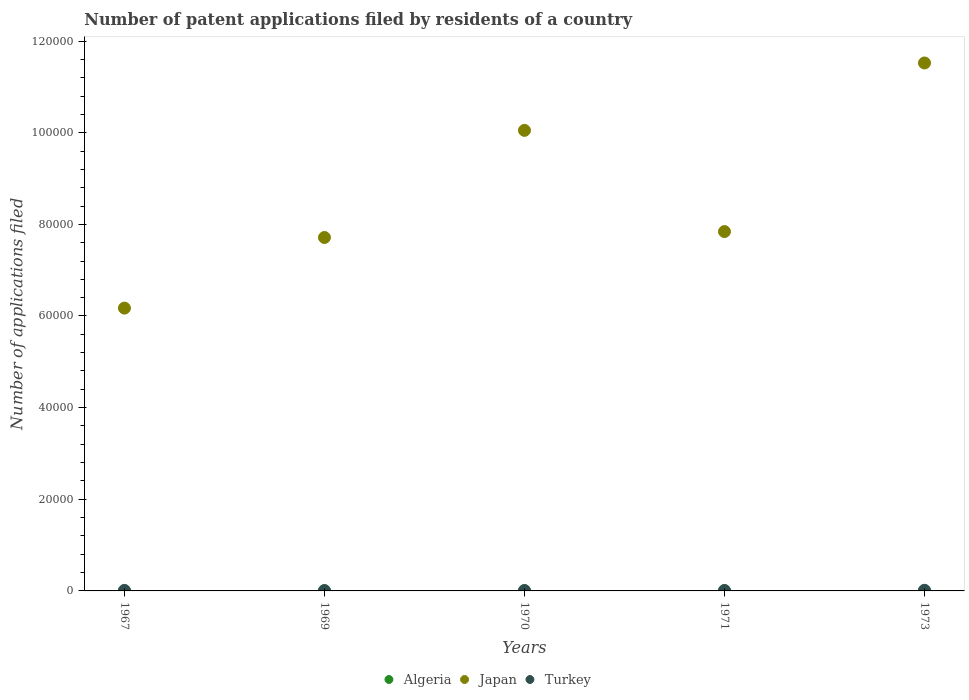Across all years, what is the maximum number of applications filed in Turkey?
Your response must be concise. 137. Across all years, what is the minimum number of applications filed in Japan?
Your answer should be very brief. 6.17e+04. In which year was the number of applications filed in Algeria minimum?
Keep it short and to the point. 1967. What is the total number of applications filed in Turkey in the graph?
Provide a short and direct response. 514. What is the difference between the number of applications filed in Algeria in 1967 and that in 1971?
Your response must be concise. -9. What is the difference between the number of applications filed in Algeria in 1969 and the number of applications filed in Japan in 1973?
Offer a very short reply. -1.15e+05. What is the average number of applications filed in Japan per year?
Offer a terse response. 8.66e+04. In the year 1971, what is the difference between the number of applications filed in Algeria and number of applications filed in Japan?
Provide a succinct answer. -7.84e+04. What is the ratio of the number of applications filed in Japan in 1967 to that in 1973?
Keep it short and to the point. 0.54. Is the number of applications filed in Algeria in 1970 less than that in 1973?
Ensure brevity in your answer.  No. Is the difference between the number of applications filed in Algeria in 1970 and 1971 greater than the difference between the number of applications filed in Japan in 1970 and 1971?
Give a very brief answer. No. What is the difference between the highest and the lowest number of applications filed in Turkey?
Keep it short and to the point. 52. In how many years, is the number of applications filed in Algeria greater than the average number of applications filed in Algeria taken over all years?
Ensure brevity in your answer.  2. Is the sum of the number of applications filed in Japan in 1967 and 1970 greater than the maximum number of applications filed in Turkey across all years?
Make the answer very short. Yes. Is it the case that in every year, the sum of the number of applications filed in Algeria and number of applications filed in Turkey  is greater than the number of applications filed in Japan?
Ensure brevity in your answer.  No. Does the number of applications filed in Japan monotonically increase over the years?
Offer a very short reply. No. Is the number of applications filed in Turkey strictly less than the number of applications filed in Algeria over the years?
Offer a very short reply. No. How many dotlines are there?
Offer a very short reply. 3. How many years are there in the graph?
Give a very brief answer. 5. What is the difference between two consecutive major ticks on the Y-axis?
Provide a succinct answer. 2.00e+04. Are the values on the major ticks of Y-axis written in scientific E-notation?
Make the answer very short. No. Does the graph contain any zero values?
Provide a short and direct response. No. Does the graph contain grids?
Make the answer very short. No. Where does the legend appear in the graph?
Offer a terse response. Bottom center. What is the title of the graph?
Offer a terse response. Number of patent applications filed by residents of a country. What is the label or title of the X-axis?
Keep it short and to the point. Years. What is the label or title of the Y-axis?
Offer a terse response. Number of applications filed. What is the Number of applications filed of Algeria in 1967?
Keep it short and to the point. 5. What is the Number of applications filed in Japan in 1967?
Provide a short and direct response. 6.17e+04. What is the Number of applications filed of Turkey in 1967?
Your answer should be very brief. 107. What is the Number of applications filed in Japan in 1969?
Offer a terse response. 7.71e+04. What is the Number of applications filed in Japan in 1970?
Keep it short and to the point. 1.01e+05. What is the Number of applications filed of Turkey in 1970?
Make the answer very short. 89. What is the Number of applications filed of Japan in 1971?
Provide a succinct answer. 7.84e+04. What is the Number of applications filed of Turkey in 1971?
Provide a succinct answer. 96. What is the Number of applications filed in Algeria in 1973?
Offer a very short reply. 7. What is the Number of applications filed in Japan in 1973?
Keep it short and to the point. 1.15e+05. What is the Number of applications filed in Turkey in 1973?
Your answer should be compact. 137. Across all years, what is the maximum Number of applications filed of Japan?
Offer a terse response. 1.15e+05. Across all years, what is the maximum Number of applications filed of Turkey?
Your response must be concise. 137. Across all years, what is the minimum Number of applications filed of Japan?
Keep it short and to the point. 6.17e+04. Across all years, what is the minimum Number of applications filed of Turkey?
Your response must be concise. 85. What is the total Number of applications filed of Algeria in the graph?
Provide a short and direct response. 51. What is the total Number of applications filed in Japan in the graph?
Give a very brief answer. 4.33e+05. What is the total Number of applications filed in Turkey in the graph?
Your answer should be very brief. 514. What is the difference between the Number of applications filed in Japan in 1967 and that in 1969?
Make the answer very short. -1.54e+04. What is the difference between the Number of applications filed in Turkey in 1967 and that in 1969?
Offer a very short reply. 22. What is the difference between the Number of applications filed of Japan in 1967 and that in 1970?
Ensure brevity in your answer.  -3.88e+04. What is the difference between the Number of applications filed in Turkey in 1967 and that in 1970?
Keep it short and to the point. 18. What is the difference between the Number of applications filed of Algeria in 1967 and that in 1971?
Offer a terse response. -9. What is the difference between the Number of applications filed of Japan in 1967 and that in 1971?
Ensure brevity in your answer.  -1.67e+04. What is the difference between the Number of applications filed of Turkey in 1967 and that in 1971?
Offer a terse response. 11. What is the difference between the Number of applications filed in Algeria in 1967 and that in 1973?
Provide a succinct answer. -2. What is the difference between the Number of applications filed of Japan in 1967 and that in 1973?
Provide a short and direct response. -5.35e+04. What is the difference between the Number of applications filed in Algeria in 1969 and that in 1970?
Offer a very short reply. -11. What is the difference between the Number of applications filed of Japan in 1969 and that in 1970?
Offer a terse response. -2.34e+04. What is the difference between the Number of applications filed in Algeria in 1969 and that in 1971?
Provide a succinct answer. -7. What is the difference between the Number of applications filed in Japan in 1969 and that in 1971?
Provide a short and direct response. -1293. What is the difference between the Number of applications filed in Algeria in 1969 and that in 1973?
Keep it short and to the point. 0. What is the difference between the Number of applications filed in Japan in 1969 and that in 1973?
Ensure brevity in your answer.  -3.81e+04. What is the difference between the Number of applications filed in Turkey in 1969 and that in 1973?
Give a very brief answer. -52. What is the difference between the Number of applications filed of Japan in 1970 and that in 1971?
Your response must be concise. 2.21e+04. What is the difference between the Number of applications filed of Algeria in 1970 and that in 1973?
Provide a succinct answer. 11. What is the difference between the Number of applications filed of Japan in 1970 and that in 1973?
Your response must be concise. -1.47e+04. What is the difference between the Number of applications filed of Turkey in 1970 and that in 1973?
Keep it short and to the point. -48. What is the difference between the Number of applications filed in Algeria in 1971 and that in 1973?
Provide a succinct answer. 7. What is the difference between the Number of applications filed in Japan in 1971 and that in 1973?
Give a very brief answer. -3.68e+04. What is the difference between the Number of applications filed of Turkey in 1971 and that in 1973?
Provide a short and direct response. -41. What is the difference between the Number of applications filed in Algeria in 1967 and the Number of applications filed in Japan in 1969?
Your answer should be compact. -7.71e+04. What is the difference between the Number of applications filed of Algeria in 1967 and the Number of applications filed of Turkey in 1969?
Provide a short and direct response. -80. What is the difference between the Number of applications filed of Japan in 1967 and the Number of applications filed of Turkey in 1969?
Your answer should be very brief. 6.16e+04. What is the difference between the Number of applications filed of Algeria in 1967 and the Number of applications filed of Japan in 1970?
Offer a terse response. -1.01e+05. What is the difference between the Number of applications filed in Algeria in 1967 and the Number of applications filed in Turkey in 1970?
Provide a succinct answer. -84. What is the difference between the Number of applications filed in Japan in 1967 and the Number of applications filed in Turkey in 1970?
Your answer should be compact. 6.16e+04. What is the difference between the Number of applications filed in Algeria in 1967 and the Number of applications filed in Japan in 1971?
Keep it short and to the point. -7.84e+04. What is the difference between the Number of applications filed of Algeria in 1967 and the Number of applications filed of Turkey in 1971?
Ensure brevity in your answer.  -91. What is the difference between the Number of applications filed in Japan in 1967 and the Number of applications filed in Turkey in 1971?
Provide a short and direct response. 6.16e+04. What is the difference between the Number of applications filed of Algeria in 1967 and the Number of applications filed of Japan in 1973?
Your response must be concise. -1.15e+05. What is the difference between the Number of applications filed in Algeria in 1967 and the Number of applications filed in Turkey in 1973?
Offer a very short reply. -132. What is the difference between the Number of applications filed of Japan in 1967 and the Number of applications filed of Turkey in 1973?
Provide a succinct answer. 6.16e+04. What is the difference between the Number of applications filed in Algeria in 1969 and the Number of applications filed in Japan in 1970?
Your answer should be very brief. -1.01e+05. What is the difference between the Number of applications filed of Algeria in 1969 and the Number of applications filed of Turkey in 1970?
Make the answer very short. -82. What is the difference between the Number of applications filed in Japan in 1969 and the Number of applications filed in Turkey in 1970?
Offer a terse response. 7.70e+04. What is the difference between the Number of applications filed in Algeria in 1969 and the Number of applications filed in Japan in 1971?
Your answer should be compact. -7.84e+04. What is the difference between the Number of applications filed in Algeria in 1969 and the Number of applications filed in Turkey in 1971?
Give a very brief answer. -89. What is the difference between the Number of applications filed in Japan in 1969 and the Number of applications filed in Turkey in 1971?
Make the answer very short. 7.70e+04. What is the difference between the Number of applications filed of Algeria in 1969 and the Number of applications filed of Japan in 1973?
Your response must be concise. -1.15e+05. What is the difference between the Number of applications filed of Algeria in 1969 and the Number of applications filed of Turkey in 1973?
Offer a very short reply. -130. What is the difference between the Number of applications filed in Japan in 1969 and the Number of applications filed in Turkey in 1973?
Your answer should be very brief. 7.70e+04. What is the difference between the Number of applications filed in Algeria in 1970 and the Number of applications filed in Japan in 1971?
Provide a short and direct response. -7.84e+04. What is the difference between the Number of applications filed in Algeria in 1970 and the Number of applications filed in Turkey in 1971?
Your answer should be compact. -78. What is the difference between the Number of applications filed in Japan in 1970 and the Number of applications filed in Turkey in 1971?
Offer a terse response. 1.00e+05. What is the difference between the Number of applications filed of Algeria in 1970 and the Number of applications filed of Japan in 1973?
Your answer should be very brief. -1.15e+05. What is the difference between the Number of applications filed in Algeria in 1970 and the Number of applications filed in Turkey in 1973?
Your response must be concise. -119. What is the difference between the Number of applications filed in Japan in 1970 and the Number of applications filed in Turkey in 1973?
Your answer should be very brief. 1.00e+05. What is the difference between the Number of applications filed in Algeria in 1971 and the Number of applications filed in Japan in 1973?
Make the answer very short. -1.15e+05. What is the difference between the Number of applications filed of Algeria in 1971 and the Number of applications filed of Turkey in 1973?
Ensure brevity in your answer.  -123. What is the difference between the Number of applications filed of Japan in 1971 and the Number of applications filed of Turkey in 1973?
Provide a succinct answer. 7.83e+04. What is the average Number of applications filed of Algeria per year?
Provide a short and direct response. 10.2. What is the average Number of applications filed in Japan per year?
Make the answer very short. 8.66e+04. What is the average Number of applications filed of Turkey per year?
Ensure brevity in your answer.  102.8. In the year 1967, what is the difference between the Number of applications filed of Algeria and Number of applications filed of Japan?
Your response must be concise. -6.17e+04. In the year 1967, what is the difference between the Number of applications filed in Algeria and Number of applications filed in Turkey?
Offer a very short reply. -102. In the year 1967, what is the difference between the Number of applications filed of Japan and Number of applications filed of Turkey?
Your answer should be very brief. 6.16e+04. In the year 1969, what is the difference between the Number of applications filed of Algeria and Number of applications filed of Japan?
Ensure brevity in your answer.  -7.71e+04. In the year 1969, what is the difference between the Number of applications filed of Algeria and Number of applications filed of Turkey?
Your response must be concise. -78. In the year 1969, what is the difference between the Number of applications filed in Japan and Number of applications filed in Turkey?
Your answer should be compact. 7.70e+04. In the year 1970, what is the difference between the Number of applications filed of Algeria and Number of applications filed of Japan?
Give a very brief answer. -1.00e+05. In the year 1970, what is the difference between the Number of applications filed in Algeria and Number of applications filed in Turkey?
Your answer should be very brief. -71. In the year 1970, what is the difference between the Number of applications filed of Japan and Number of applications filed of Turkey?
Offer a terse response. 1.00e+05. In the year 1971, what is the difference between the Number of applications filed of Algeria and Number of applications filed of Japan?
Offer a very short reply. -7.84e+04. In the year 1971, what is the difference between the Number of applications filed in Algeria and Number of applications filed in Turkey?
Your response must be concise. -82. In the year 1971, what is the difference between the Number of applications filed of Japan and Number of applications filed of Turkey?
Your answer should be very brief. 7.83e+04. In the year 1973, what is the difference between the Number of applications filed of Algeria and Number of applications filed of Japan?
Make the answer very short. -1.15e+05. In the year 1973, what is the difference between the Number of applications filed of Algeria and Number of applications filed of Turkey?
Keep it short and to the point. -130. In the year 1973, what is the difference between the Number of applications filed in Japan and Number of applications filed in Turkey?
Offer a terse response. 1.15e+05. What is the ratio of the Number of applications filed of Japan in 1967 to that in 1969?
Offer a very short reply. 0.8. What is the ratio of the Number of applications filed in Turkey in 1967 to that in 1969?
Keep it short and to the point. 1.26. What is the ratio of the Number of applications filed in Algeria in 1967 to that in 1970?
Your response must be concise. 0.28. What is the ratio of the Number of applications filed of Japan in 1967 to that in 1970?
Give a very brief answer. 0.61. What is the ratio of the Number of applications filed in Turkey in 1967 to that in 1970?
Your response must be concise. 1.2. What is the ratio of the Number of applications filed of Algeria in 1967 to that in 1971?
Give a very brief answer. 0.36. What is the ratio of the Number of applications filed of Japan in 1967 to that in 1971?
Ensure brevity in your answer.  0.79. What is the ratio of the Number of applications filed of Turkey in 1967 to that in 1971?
Provide a succinct answer. 1.11. What is the ratio of the Number of applications filed of Algeria in 1967 to that in 1973?
Your answer should be very brief. 0.71. What is the ratio of the Number of applications filed in Japan in 1967 to that in 1973?
Offer a very short reply. 0.54. What is the ratio of the Number of applications filed of Turkey in 1967 to that in 1973?
Keep it short and to the point. 0.78. What is the ratio of the Number of applications filed in Algeria in 1969 to that in 1970?
Provide a short and direct response. 0.39. What is the ratio of the Number of applications filed of Japan in 1969 to that in 1970?
Make the answer very short. 0.77. What is the ratio of the Number of applications filed of Turkey in 1969 to that in 1970?
Keep it short and to the point. 0.96. What is the ratio of the Number of applications filed in Algeria in 1969 to that in 1971?
Provide a succinct answer. 0.5. What is the ratio of the Number of applications filed in Japan in 1969 to that in 1971?
Make the answer very short. 0.98. What is the ratio of the Number of applications filed of Turkey in 1969 to that in 1971?
Your answer should be compact. 0.89. What is the ratio of the Number of applications filed of Japan in 1969 to that in 1973?
Provide a short and direct response. 0.67. What is the ratio of the Number of applications filed in Turkey in 1969 to that in 1973?
Your answer should be compact. 0.62. What is the ratio of the Number of applications filed in Algeria in 1970 to that in 1971?
Give a very brief answer. 1.29. What is the ratio of the Number of applications filed of Japan in 1970 to that in 1971?
Ensure brevity in your answer.  1.28. What is the ratio of the Number of applications filed in Turkey in 1970 to that in 1971?
Ensure brevity in your answer.  0.93. What is the ratio of the Number of applications filed in Algeria in 1970 to that in 1973?
Your response must be concise. 2.57. What is the ratio of the Number of applications filed of Japan in 1970 to that in 1973?
Your response must be concise. 0.87. What is the ratio of the Number of applications filed of Turkey in 1970 to that in 1973?
Provide a short and direct response. 0.65. What is the ratio of the Number of applications filed in Japan in 1971 to that in 1973?
Provide a succinct answer. 0.68. What is the ratio of the Number of applications filed in Turkey in 1971 to that in 1973?
Offer a terse response. 0.7. What is the difference between the highest and the second highest Number of applications filed in Algeria?
Provide a short and direct response. 4. What is the difference between the highest and the second highest Number of applications filed in Japan?
Keep it short and to the point. 1.47e+04. What is the difference between the highest and the lowest Number of applications filed in Algeria?
Your answer should be very brief. 13. What is the difference between the highest and the lowest Number of applications filed of Japan?
Provide a succinct answer. 5.35e+04. 